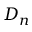<formula> <loc_0><loc_0><loc_500><loc_500>D _ { n }</formula> 